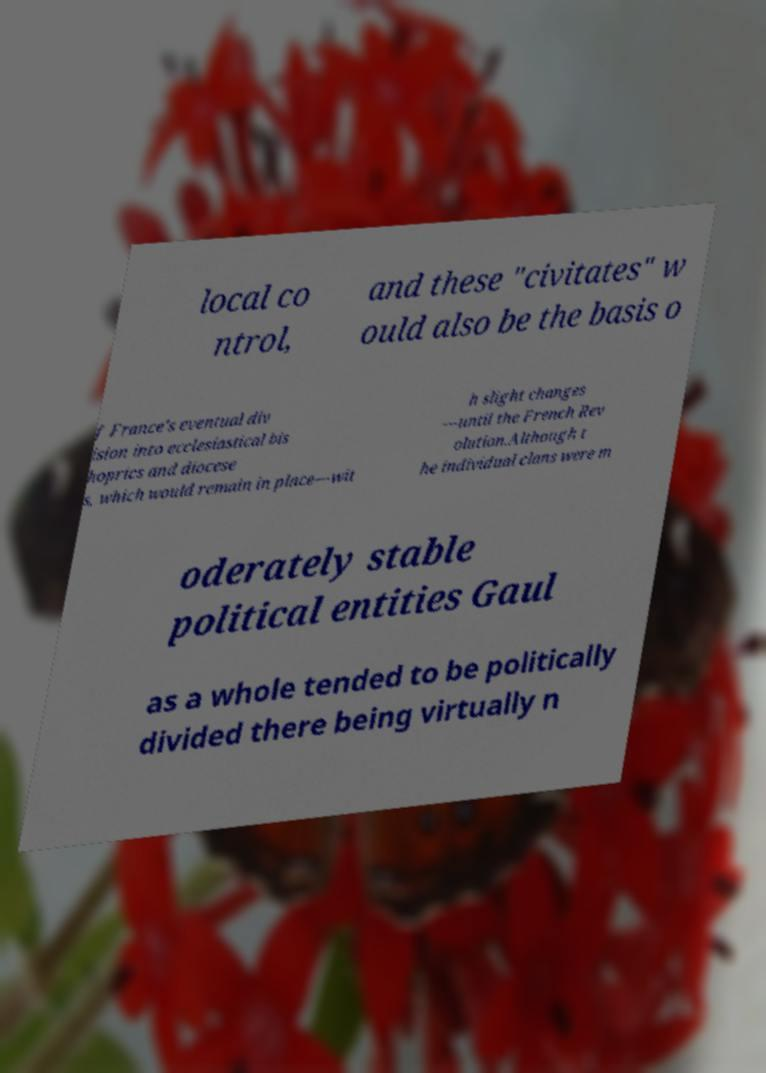Can you accurately transcribe the text from the provided image for me? local co ntrol, and these "civitates" w ould also be the basis o f France's eventual div ision into ecclesiastical bis hoprics and diocese s, which would remain in place—wit h slight changes —until the French Rev olution.Although t he individual clans were m oderately stable political entities Gaul as a whole tended to be politically divided there being virtually n 